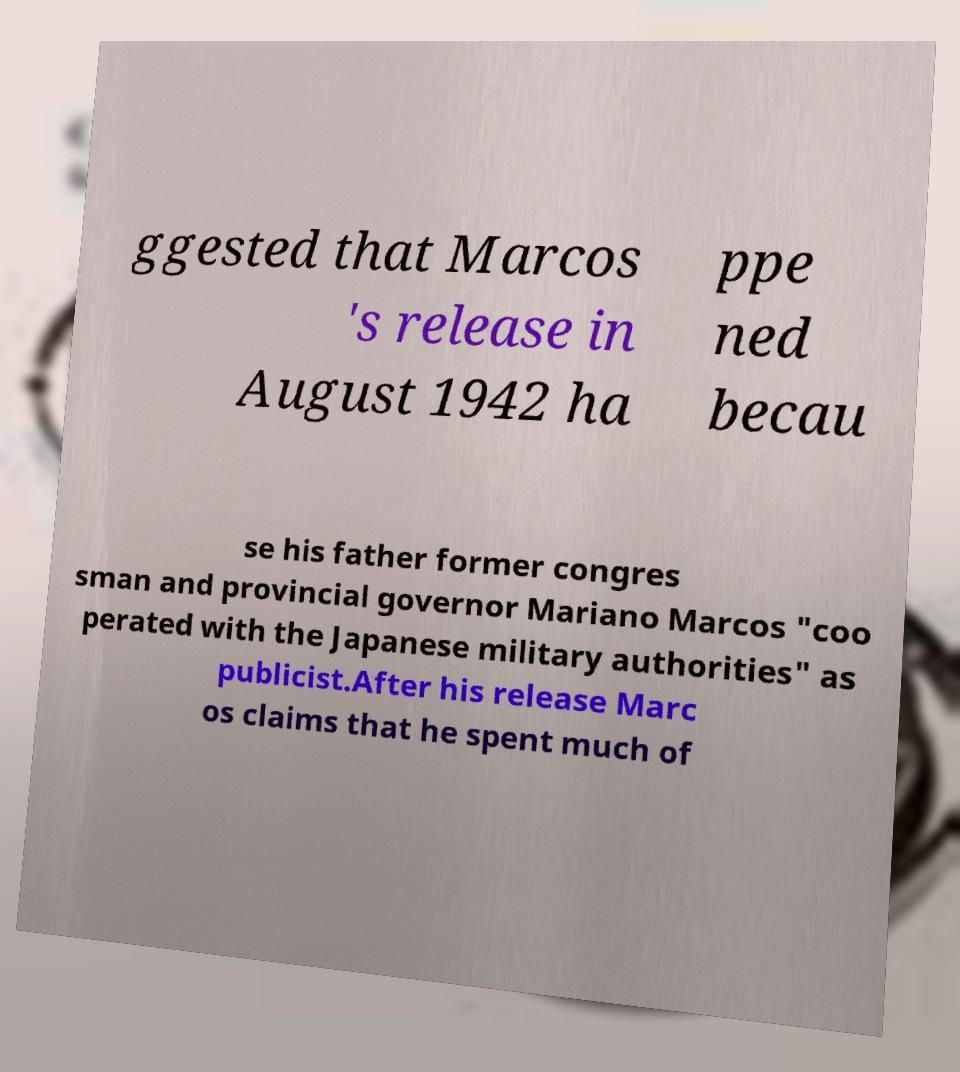Can you accurately transcribe the text from the provided image for me? ggested that Marcos 's release in August 1942 ha ppe ned becau se his father former congres sman and provincial governor Mariano Marcos "coo perated with the Japanese military authorities" as publicist.After his release Marc os claims that he spent much of 